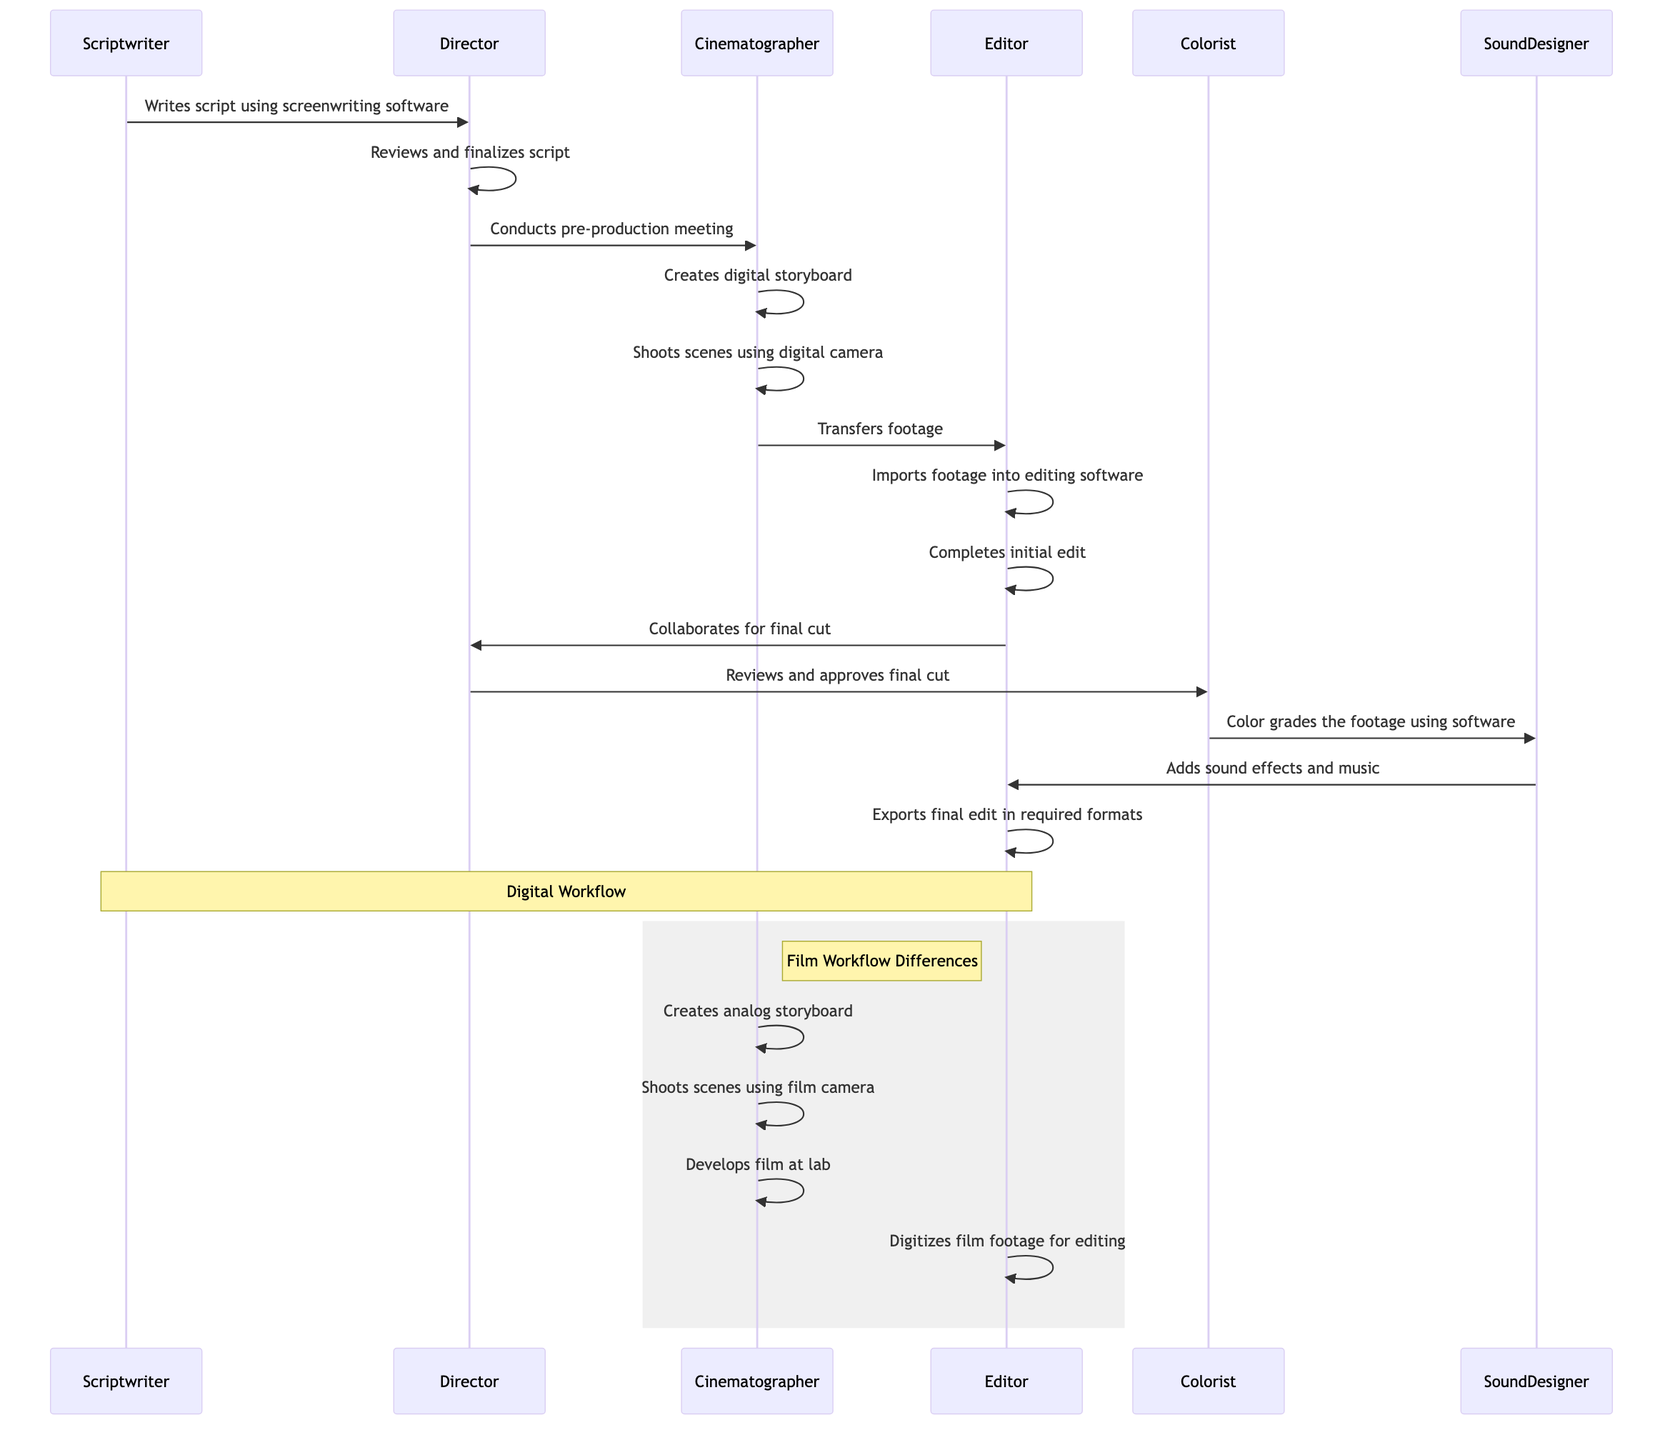What is the first action in the digital workflow? The first action in the digital workflow is the scriptwriter writing the script using screenwriting software. This can be seen in the initial step where the scriptwriter is the actor and the action is clearly stated.
Answer: Writes script using screenwriting software How many main actors are involved in the digital workflow? The digital workflow involves six main actors: Scriptwriter, Director, Cinematographer, Editor, Colorist, and Sound Designer. Each actor is distinctly represented in the workflow, and counting those listed gives the total.
Answer: Six What step follows the completion of the initial edit in both workflows? In both workflows, the step that follows the completion of the initial edit is the collaboration with the Director for the final cut, identified by the repeated action in both workflows after the initial edit step.
Answer: Collaborates with Director for final cut What type of storyboard is created during the film workflow? The type of storyboard created during the film workflow is an analog storyboard. This is specifically mentioned in the film workflow section of the diagram.
Answer: Analog storyboard How does the cinematographer's shooting method differ between digital and film workflows? In the digital workflow, the cinematographer shoots scenes using a digital camera, whereas in the film workflow, the cinematographer shoots scenes using a film camera. This demonstrates the key distinction in the equipment used.
Answer: Digital camera; Film camera What action does the sound designer take before the final export in both workflows? The action taken by the sound designer before the final export in both workflows is to add sound effects and music. This consistent action indicates their role in both production processes.
Answer: Adds sound effects and music Which actor reviews and approves the final cut? The actor who reviews and approves the final cut is the Director, as indicated by the workflow steps leading to this decision, showing their supervisory role.
Answer: Director How does the film workflow handle the film footage after shooting? After shooting, the film footage is developed in a lab, which is a unique step in the film workflow, as it involves physical processing that is not present in the digital workflow.
Answer: Develops film at lab 